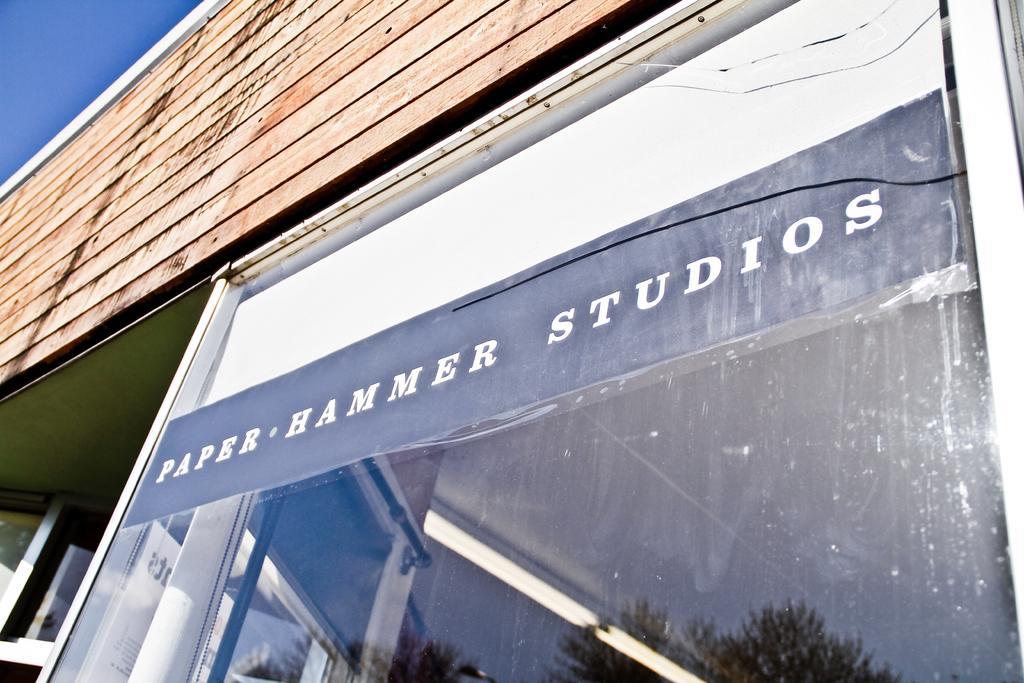Please provide a concise description of this image. In this picture, we can see the wall of a building, with glass door, and we can see some text and some reflections on the glass, we can see the sky. 